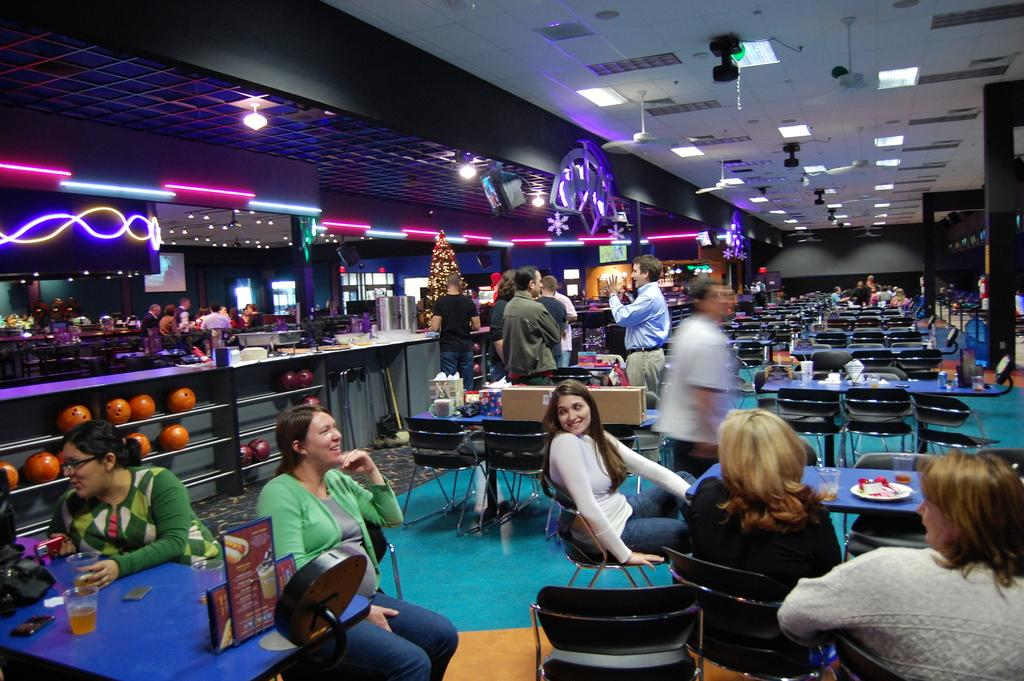What type of establishment is shown in the image? The image depicts a cafeteria. What furniture is present in the cafeteria? There are dining tables and chairs in the cafeteria. What are the people in the image doing? People are standing and sitting at the tables. What type of lighting is present in the cafeteria? There are lamps in the cafeteria. What type of food can be seen in the image? There are fruits in a rack. What type of paste is being used to stick the fruits to the rack? There is no paste visible in the image, and the fruits are not stuck to the rack; they are simply placed in it. 